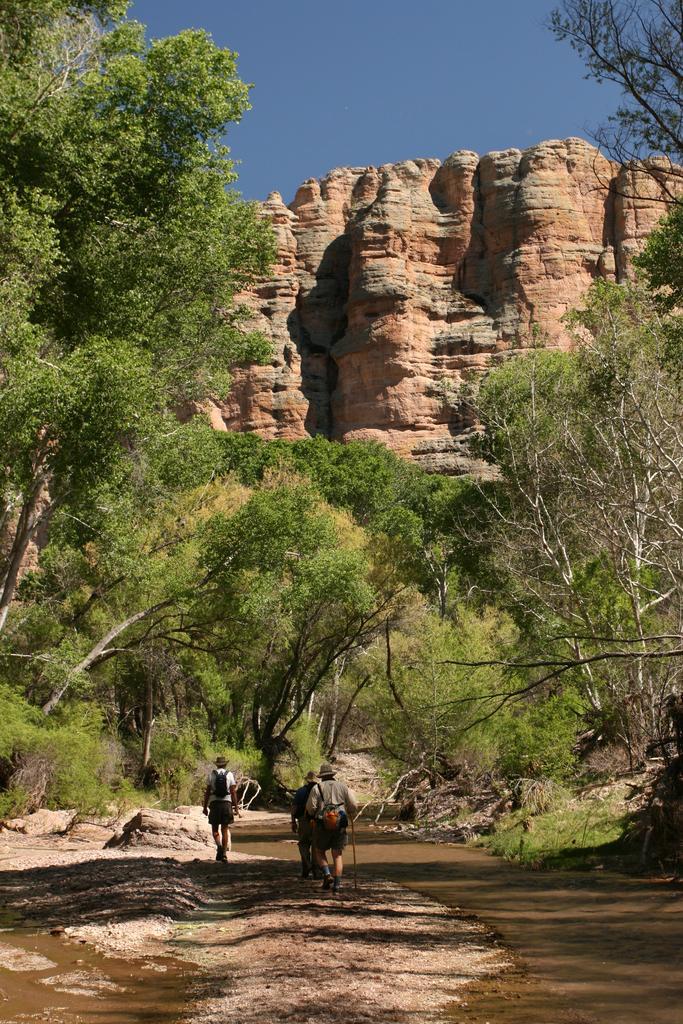How would you summarize this image in a sentence or two? In this image we can see three persons wearing a hat standing on the ground. One person is carrying a bag. In the background, we can see a group of trees, mountain, water and the sky. 